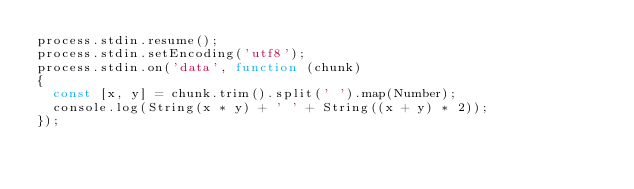Convert code to text. <code><loc_0><loc_0><loc_500><loc_500><_JavaScript_>process.stdin.resume();
process.stdin.setEncoding('utf8');
process.stdin.on('data', function (chunk)
{
  const [x, y] = chunk.trim().split(' ').map(Number);
  console.log(String(x * y) + ' ' + String((x + y) * 2));
});</code> 